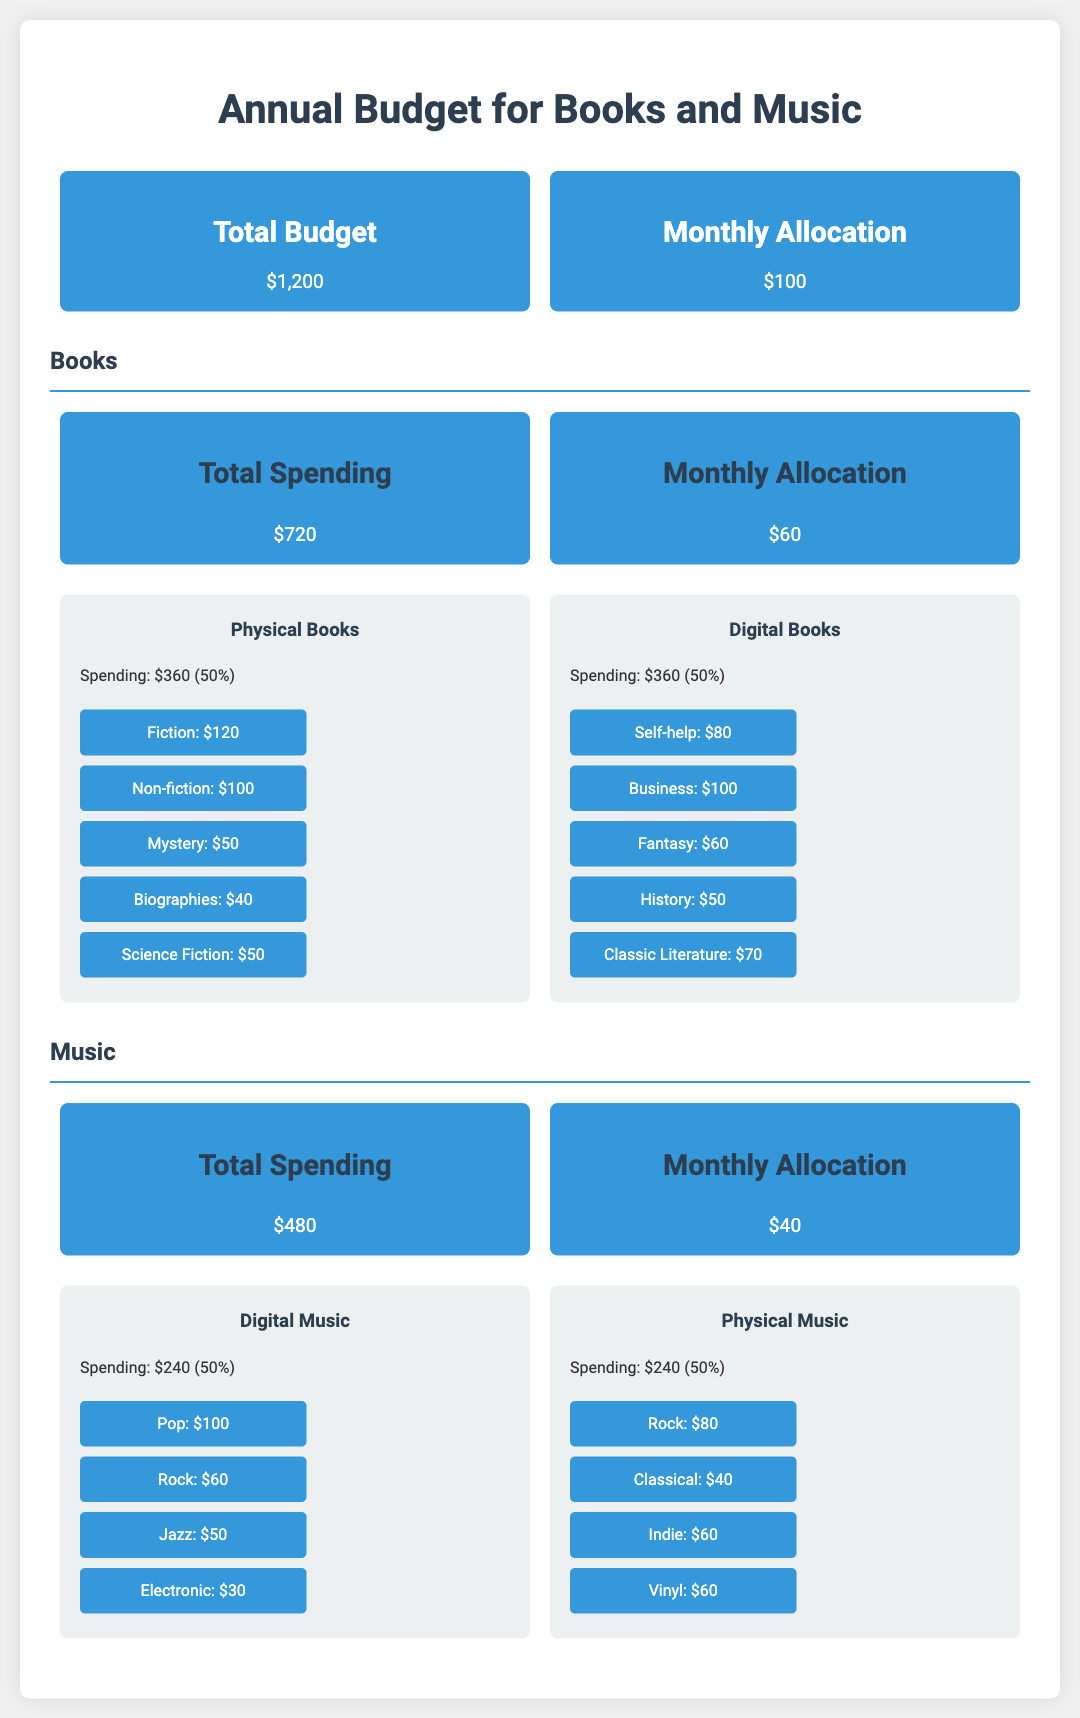What is the total budget for books and music? The total budget is stated clearly in the document under the budget overview section.
Answer: $1,200 How much is allocated monthly for music? The budget document specifies the monthly allocation for music in the music category.
Answer: $40 What genre has the highest spending in physical books? By reviewing the spending breakdown of genres in physical books, the answer can be identified.
Answer: Fiction What percentage of total spending is allocated to digital music? This involves calculating the percentage based on the total spending in the music section.
Answer: 50% What is the total spending on digital books? The digital books category provides the total amount spent on that format directly.
Answer: $360 Which genre of music has the lowest spending in physical format? Reviewing the breakdown in physical music, the lowest spending can be determined.
Answer: Classical How much is the total spending on books? The total spending is clearly listed in the books section of the budget.
Answer: $720 What genre of books received the least amount of spending? This can be determined by checking the genre spending within the books section.
Answer: Biographies What is the monthly allocation for books? The monthly budget allocation for books is specified in the document, making it easy to find.
Answer: $60 